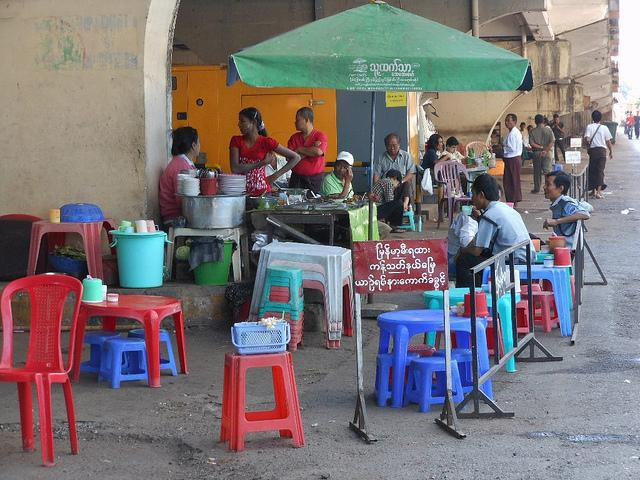What are the colored plastic objects for? sitting 